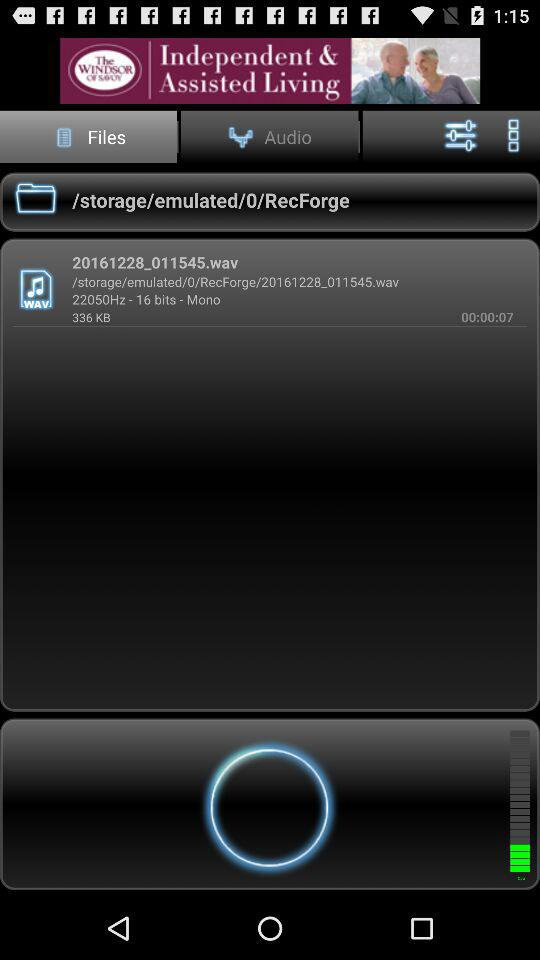What is the name of the audio file? The name of the audio file is 20161228_011545.wav. 